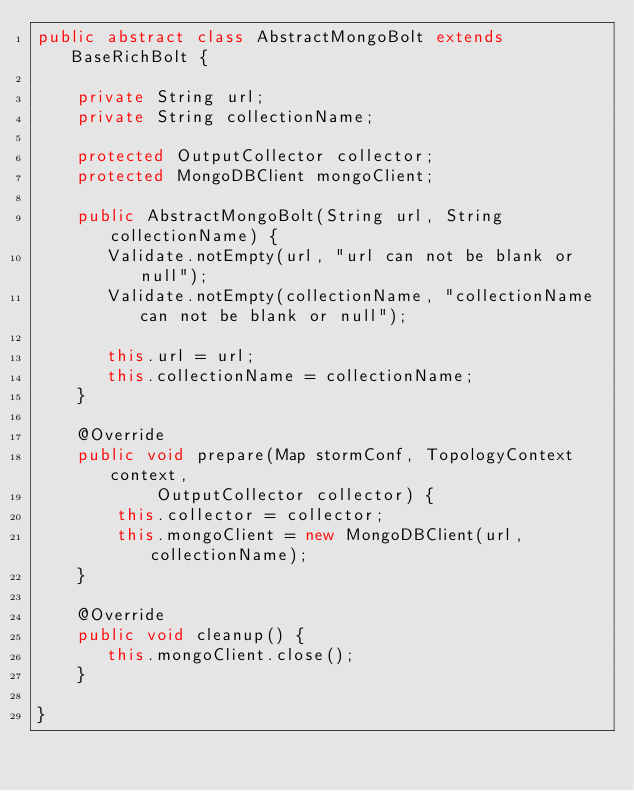Convert code to text. <code><loc_0><loc_0><loc_500><loc_500><_Java_>public abstract class AbstractMongoBolt extends BaseRichBolt {

    private String url;
    private String collectionName;

    protected OutputCollector collector;
    protected MongoDBClient mongoClient;

    public AbstractMongoBolt(String url, String collectionName) {
       Validate.notEmpty(url, "url can not be blank or null");
       Validate.notEmpty(collectionName, "collectionName can not be blank or null");

       this.url = url;
       this.collectionName = collectionName;
    }

    @Override
    public void prepare(Map stormConf, TopologyContext context,
            OutputCollector collector) {
        this.collector = collector;
        this.mongoClient = new MongoDBClient(url, collectionName);
    }

    @Override
    public void cleanup() {
       this.mongoClient.close();
    }

}
</code> 